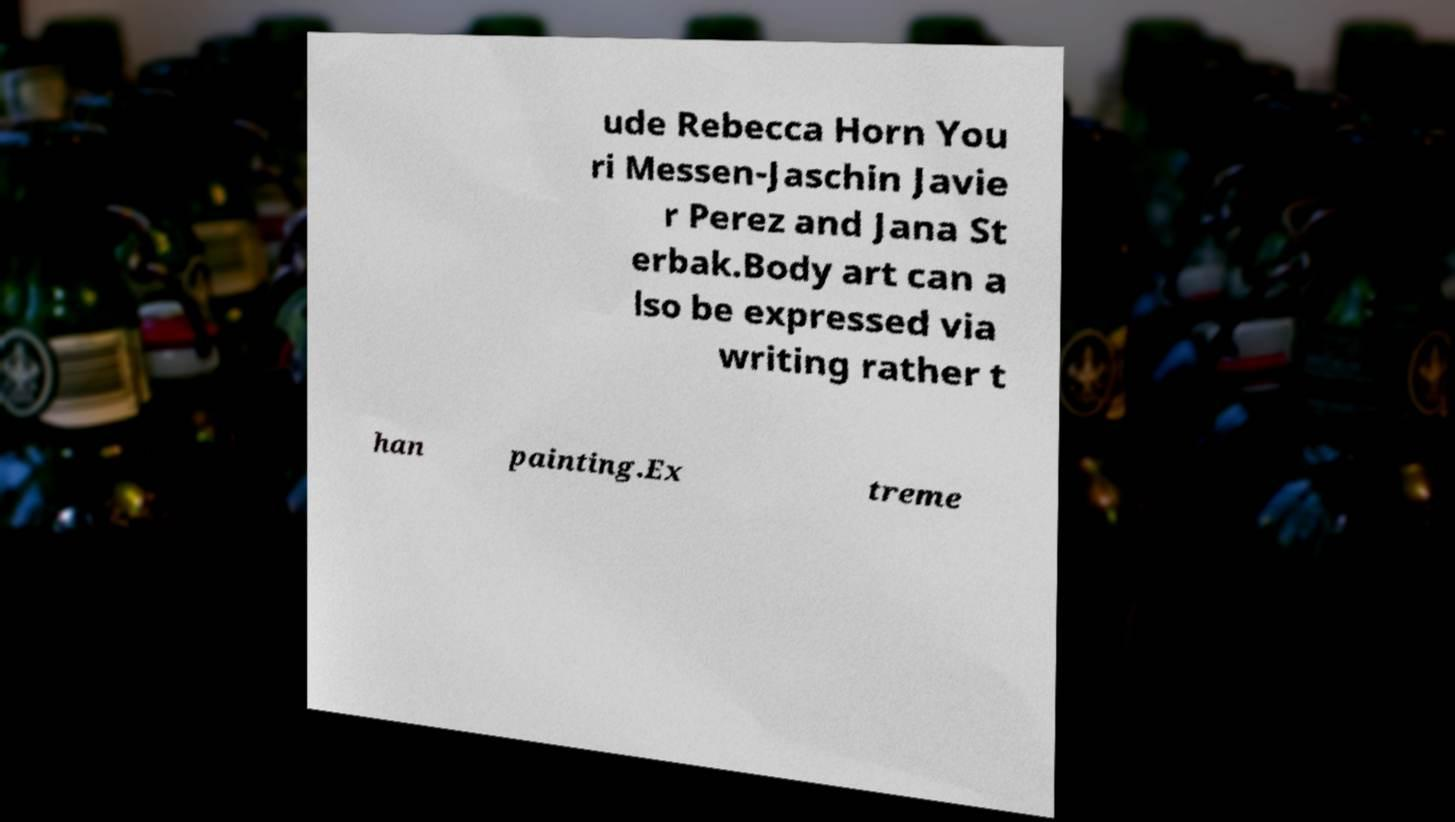Could you assist in decoding the text presented in this image and type it out clearly? ude Rebecca Horn You ri Messen-Jaschin Javie r Perez and Jana St erbak.Body art can a lso be expressed via writing rather t han painting.Ex treme 